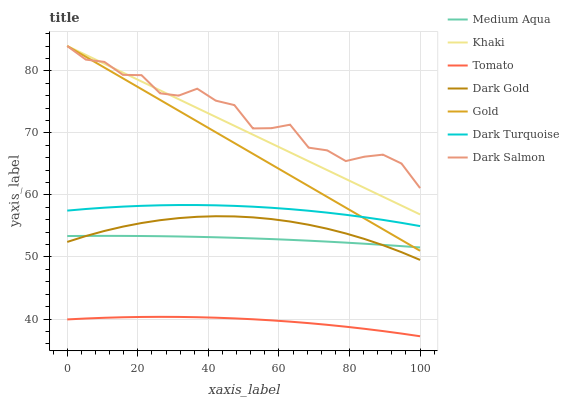Does Tomato have the minimum area under the curve?
Answer yes or no. Yes. Does Dark Salmon have the maximum area under the curve?
Answer yes or no. Yes. Does Khaki have the minimum area under the curve?
Answer yes or no. No. Does Khaki have the maximum area under the curve?
Answer yes or no. No. Is Gold the smoothest?
Answer yes or no. Yes. Is Dark Salmon the roughest?
Answer yes or no. Yes. Is Khaki the smoothest?
Answer yes or no. No. Is Khaki the roughest?
Answer yes or no. No. Does Khaki have the lowest value?
Answer yes or no. No. Does Dark Gold have the highest value?
Answer yes or no. No. Is Dark Turquoise less than Khaki?
Answer yes or no. Yes. Is Gold greater than Dark Gold?
Answer yes or no. Yes. Does Dark Turquoise intersect Khaki?
Answer yes or no. No. 